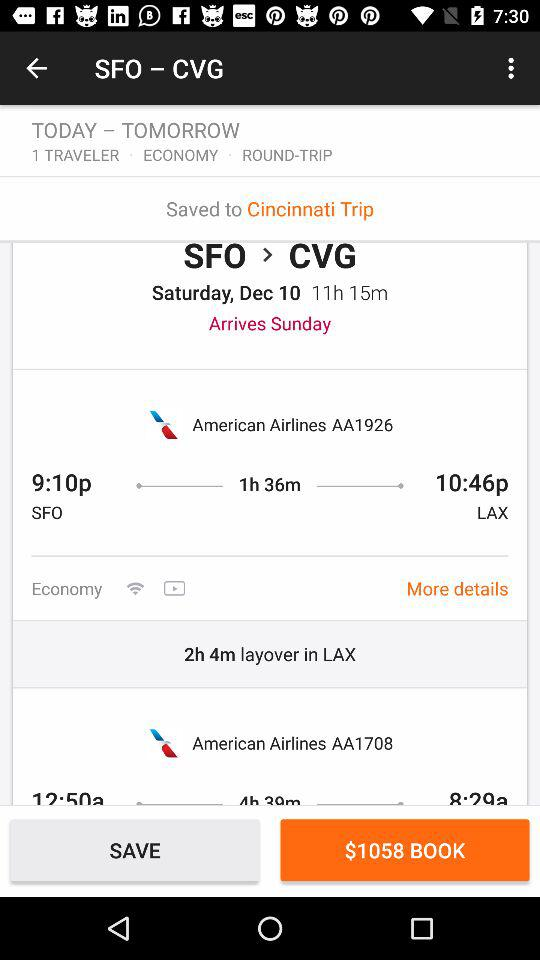What is the type of the trip? The type of the trip is round trip. 